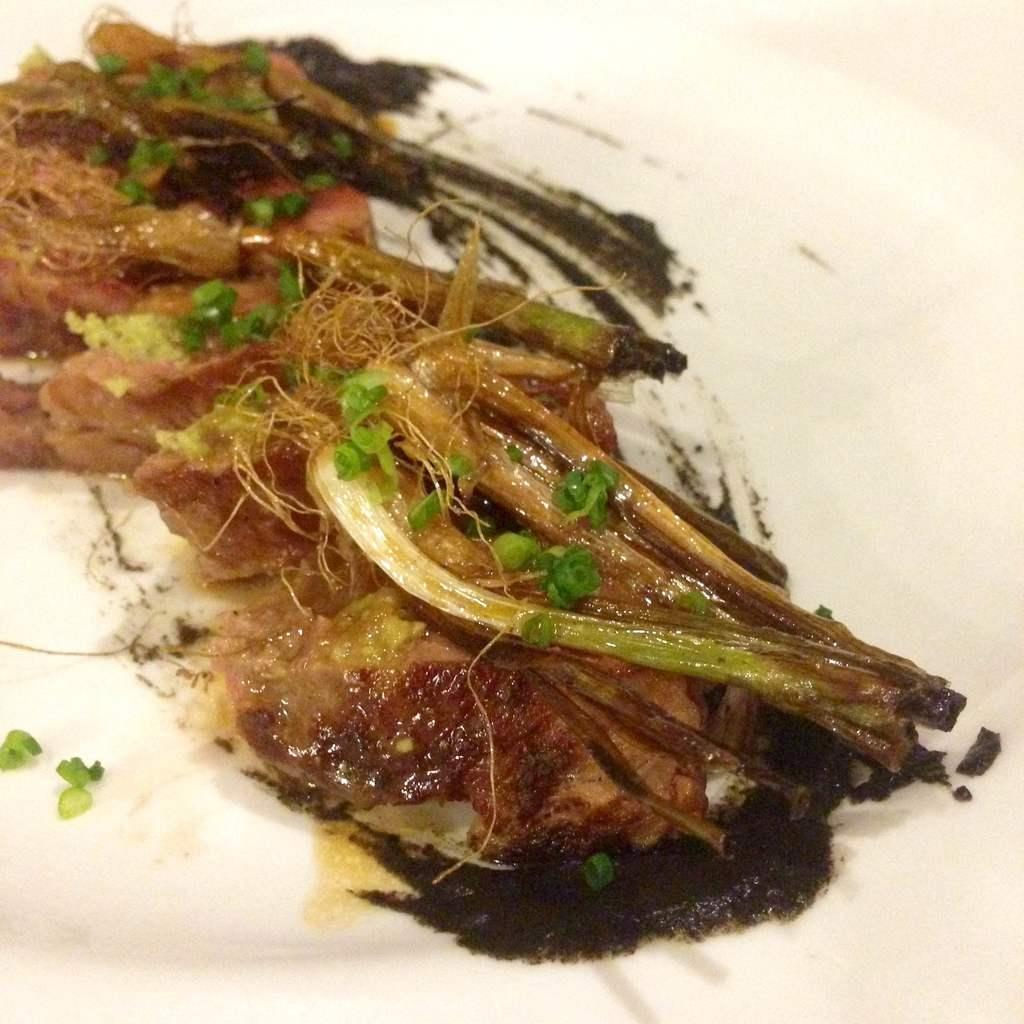What type of food can be seen in the image? There is cooked food in the image. How is the cooked food presented? The cooked food is served on a plate. Are there any bears eating the cooked food in the image? No, there are no bears present in the image. 